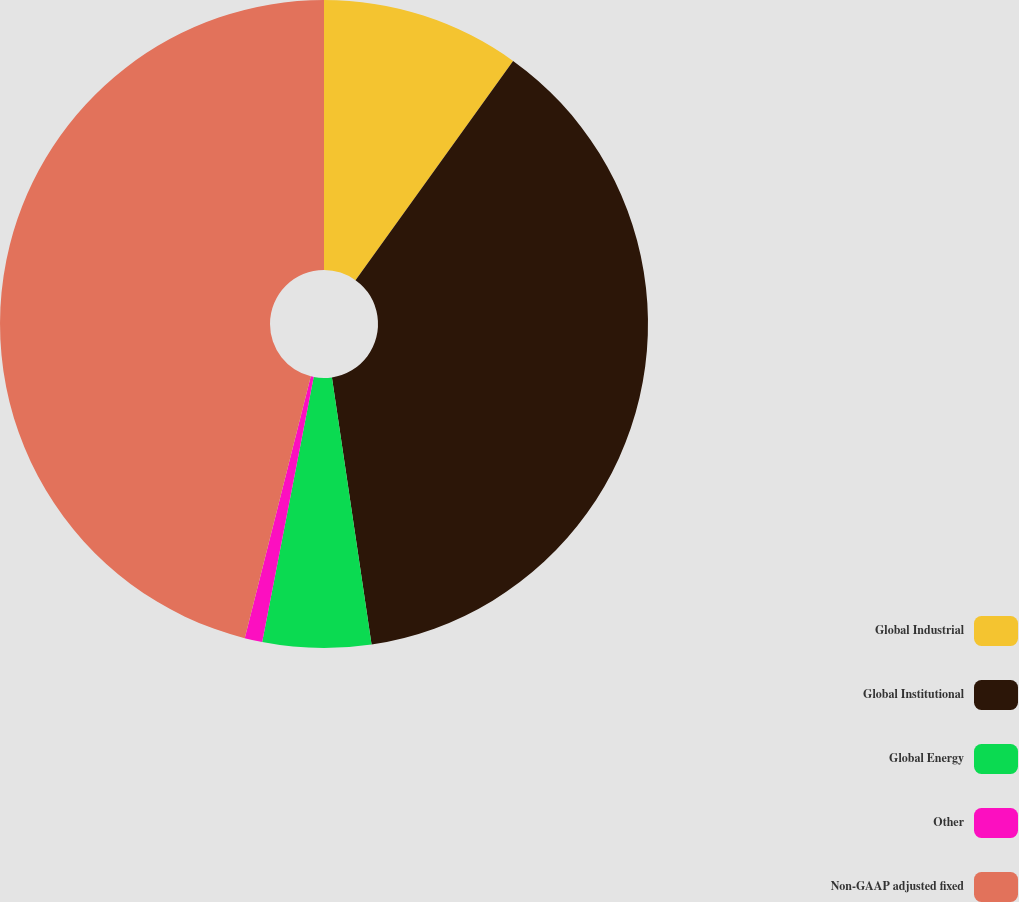Convert chart to OTSL. <chart><loc_0><loc_0><loc_500><loc_500><pie_chart><fcel>Global Industrial<fcel>Global Institutional<fcel>Global Energy<fcel>Other<fcel>Non-GAAP adjusted fixed<nl><fcel>9.92%<fcel>37.74%<fcel>5.4%<fcel>0.88%<fcel>46.07%<nl></chart> 